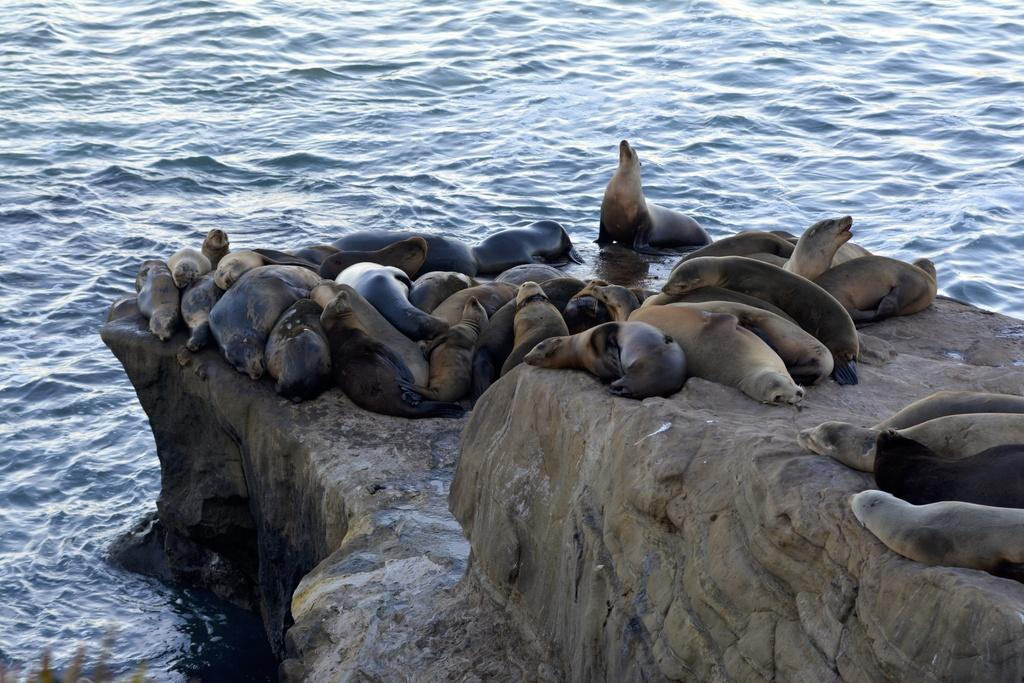What animals are present in the image? There are many seals in the image. Where are the seals located? The seals are lying on a rock. What can be seen in the background of the image? There is water visible in the image. What arithmetic problem are the seals solving in the image? There is no arithmetic problem present in the image; it features seals lying on a rock. How do the seals say good-bye to each other in the image? There is no indication of the seals saying good-bye to each other in the image. 